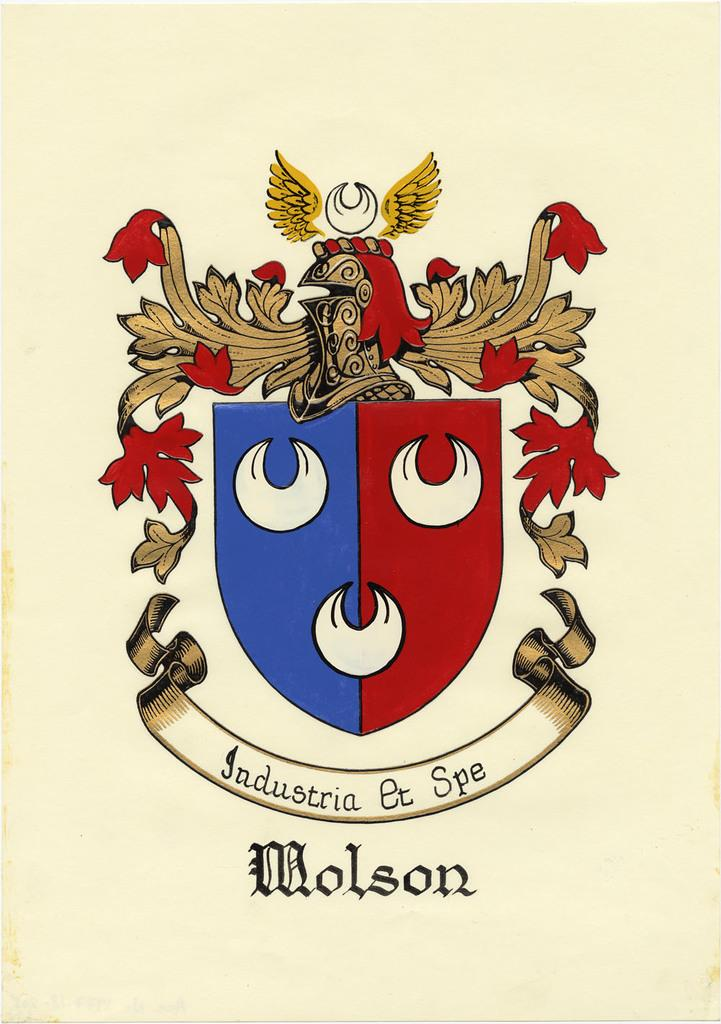Provide a one-sentence caption for the provided image. Coat of arms for a nation of a country named Molson. 